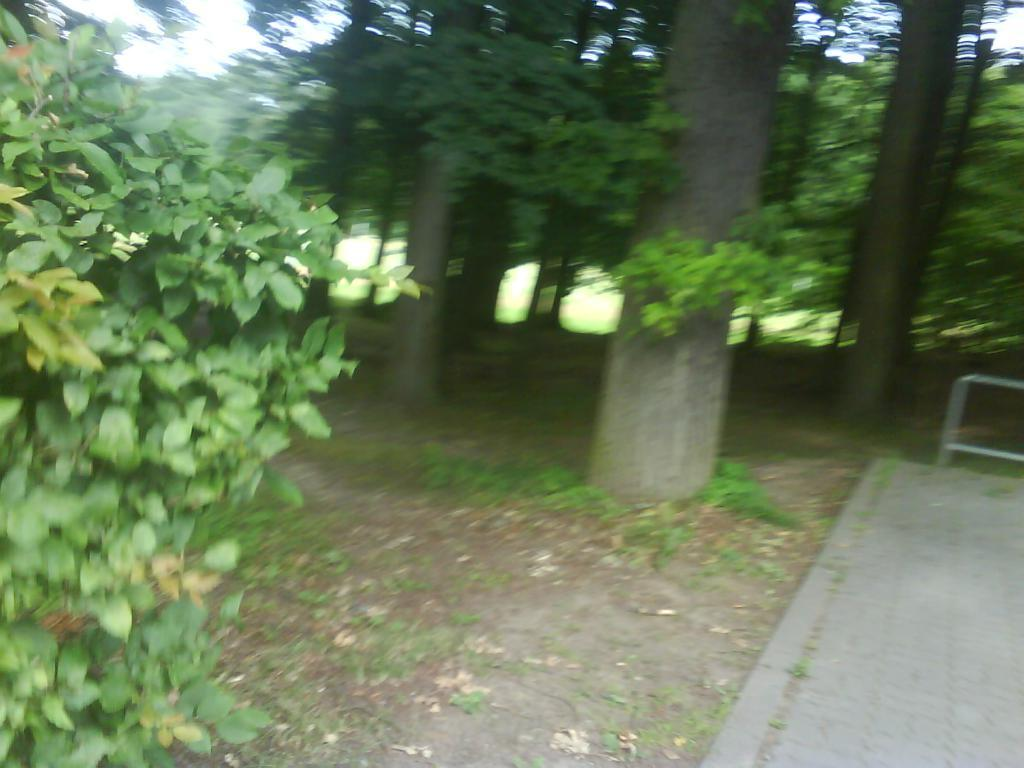What type of vegetation can be seen in the image? There are trees, plants, and grass visible in the image. What is the ground covered with in the image? Soil is visible on the floor in the image. How many straws are being used by the rabbits in the image? There are no straws or rabbits present in the image. What type of engine can be seen powering the plants in the image? There is no engine present in the image, and plants do not require engines to function. 